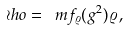Convert formula to latex. <formula><loc_0><loc_0><loc_500><loc_500>\wr h o = \ m f _ { \varrho } ( g ^ { 2 } ) \varrho \, ,</formula> 